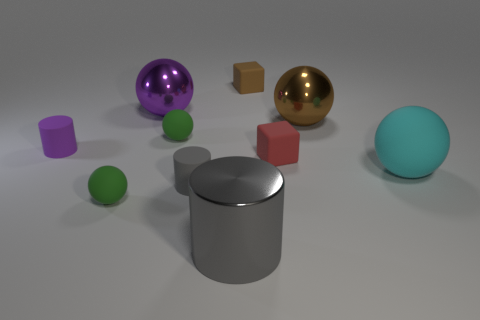There is a tiny cylinder that is the same color as the big shiny cylinder; what material is it?
Make the answer very short. Rubber. Is the number of green rubber balls that are in front of the cyan ball greater than the number of tiny purple objects that are right of the gray matte thing?
Your response must be concise. Yes. There is a shiny object on the left side of the big metal cylinder; does it have the same color as the large shiny cylinder?
Keep it short and to the point. No. The red block is what size?
Provide a succinct answer. Small. There is a brown thing that is the same size as the red object; what is its material?
Offer a terse response. Rubber. What color is the small matte sphere that is behind the big cyan object?
Your answer should be very brief. Green. How many purple cylinders are there?
Provide a short and direct response. 1. There is a tiny ball that is behind the green sphere that is in front of the red thing; are there any brown spheres on the left side of it?
Make the answer very short. No. The gray thing that is the same size as the brown metal sphere is what shape?
Keep it short and to the point. Cylinder. What number of other objects are there of the same color as the metallic cylinder?
Make the answer very short. 1. 